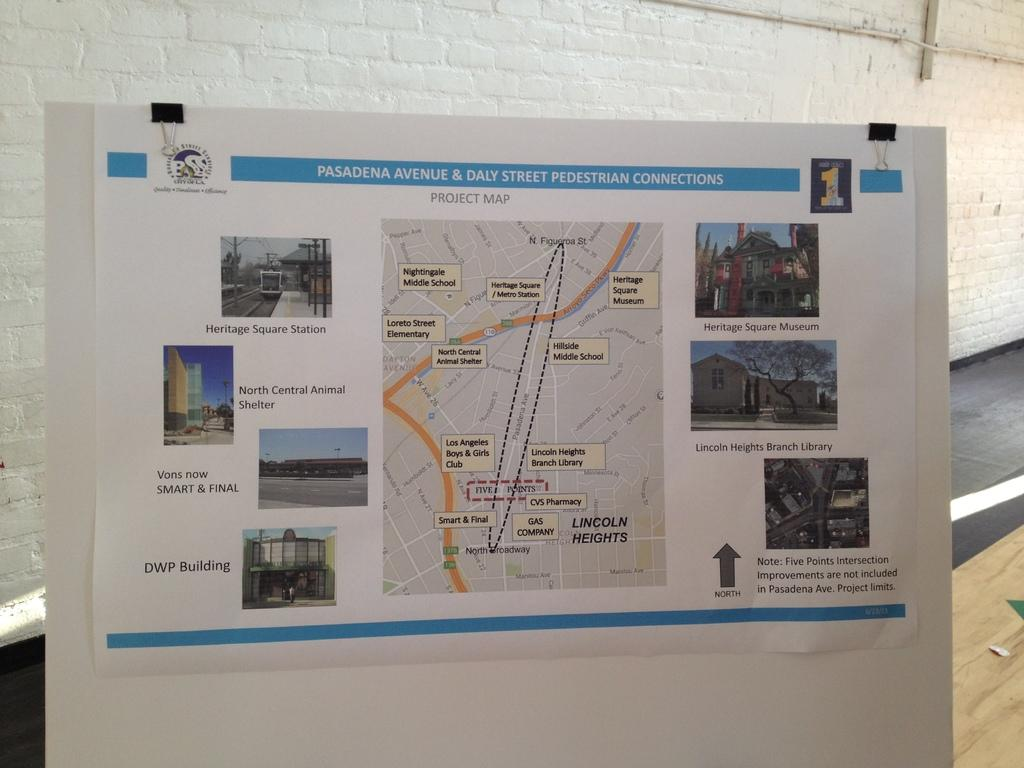<image>
Summarize the visual content of the image. paper map of the city of pasadena ca 